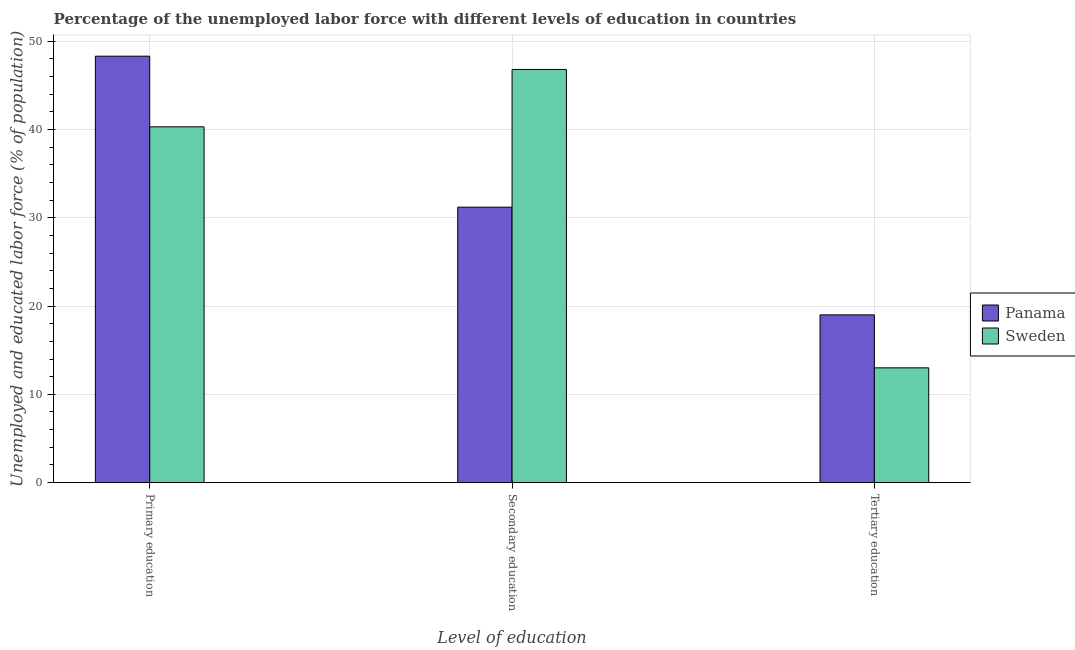How many different coloured bars are there?
Offer a terse response. 2. Are the number of bars per tick equal to the number of legend labels?
Your answer should be compact. Yes. What is the label of the 2nd group of bars from the left?
Provide a short and direct response. Secondary education. What is the percentage of labor force who received secondary education in Sweden?
Your response must be concise. 46.8. Across all countries, what is the maximum percentage of labor force who received secondary education?
Keep it short and to the point. 46.8. Across all countries, what is the minimum percentage of labor force who received primary education?
Give a very brief answer. 40.3. In which country was the percentage of labor force who received tertiary education maximum?
Provide a succinct answer. Panama. What is the total percentage of labor force who received primary education in the graph?
Provide a succinct answer. 88.6. What is the difference between the percentage of labor force who received secondary education in Sweden and that in Panama?
Your response must be concise. 15.6. What is the difference between the percentage of labor force who received primary education in Sweden and the percentage of labor force who received tertiary education in Panama?
Make the answer very short. 21.3. What is the difference between the percentage of labor force who received primary education and percentage of labor force who received tertiary education in Panama?
Keep it short and to the point. 29.3. What is the ratio of the percentage of labor force who received secondary education in Panama to that in Sweden?
Offer a very short reply. 0.67. What is the difference between the highest and the second highest percentage of labor force who received tertiary education?
Provide a short and direct response. 6. What is the difference between the highest and the lowest percentage of labor force who received tertiary education?
Your answer should be very brief. 6. Is the sum of the percentage of labor force who received secondary education in Panama and Sweden greater than the maximum percentage of labor force who received tertiary education across all countries?
Your answer should be compact. Yes. What does the 2nd bar from the right in Primary education represents?
Offer a very short reply. Panama. Is it the case that in every country, the sum of the percentage of labor force who received primary education and percentage of labor force who received secondary education is greater than the percentage of labor force who received tertiary education?
Ensure brevity in your answer.  Yes. Are all the bars in the graph horizontal?
Your answer should be compact. No. Are the values on the major ticks of Y-axis written in scientific E-notation?
Keep it short and to the point. No. Does the graph contain any zero values?
Ensure brevity in your answer.  No. Does the graph contain grids?
Offer a terse response. Yes. Where does the legend appear in the graph?
Provide a short and direct response. Center right. How many legend labels are there?
Keep it short and to the point. 2. How are the legend labels stacked?
Your response must be concise. Vertical. What is the title of the graph?
Make the answer very short. Percentage of the unemployed labor force with different levels of education in countries. Does "Sierra Leone" appear as one of the legend labels in the graph?
Your answer should be very brief. No. What is the label or title of the X-axis?
Your response must be concise. Level of education. What is the label or title of the Y-axis?
Provide a short and direct response. Unemployed and educated labor force (% of population). What is the Unemployed and educated labor force (% of population) in Panama in Primary education?
Your answer should be compact. 48.3. What is the Unemployed and educated labor force (% of population) in Sweden in Primary education?
Provide a succinct answer. 40.3. What is the Unemployed and educated labor force (% of population) of Panama in Secondary education?
Provide a short and direct response. 31.2. What is the Unemployed and educated labor force (% of population) in Sweden in Secondary education?
Your answer should be very brief. 46.8. Across all Level of education, what is the maximum Unemployed and educated labor force (% of population) in Panama?
Ensure brevity in your answer.  48.3. Across all Level of education, what is the maximum Unemployed and educated labor force (% of population) in Sweden?
Offer a terse response. 46.8. Across all Level of education, what is the minimum Unemployed and educated labor force (% of population) in Panama?
Keep it short and to the point. 19. Across all Level of education, what is the minimum Unemployed and educated labor force (% of population) in Sweden?
Offer a very short reply. 13. What is the total Unemployed and educated labor force (% of population) in Panama in the graph?
Make the answer very short. 98.5. What is the total Unemployed and educated labor force (% of population) in Sweden in the graph?
Give a very brief answer. 100.1. What is the difference between the Unemployed and educated labor force (% of population) in Panama in Primary education and that in Secondary education?
Your answer should be very brief. 17.1. What is the difference between the Unemployed and educated labor force (% of population) in Sweden in Primary education and that in Secondary education?
Keep it short and to the point. -6.5. What is the difference between the Unemployed and educated labor force (% of population) in Panama in Primary education and that in Tertiary education?
Offer a very short reply. 29.3. What is the difference between the Unemployed and educated labor force (% of population) of Sweden in Primary education and that in Tertiary education?
Provide a succinct answer. 27.3. What is the difference between the Unemployed and educated labor force (% of population) of Sweden in Secondary education and that in Tertiary education?
Your response must be concise. 33.8. What is the difference between the Unemployed and educated labor force (% of population) in Panama in Primary education and the Unemployed and educated labor force (% of population) in Sweden in Tertiary education?
Provide a short and direct response. 35.3. What is the average Unemployed and educated labor force (% of population) in Panama per Level of education?
Ensure brevity in your answer.  32.83. What is the average Unemployed and educated labor force (% of population) in Sweden per Level of education?
Give a very brief answer. 33.37. What is the difference between the Unemployed and educated labor force (% of population) of Panama and Unemployed and educated labor force (% of population) of Sweden in Primary education?
Offer a terse response. 8. What is the difference between the Unemployed and educated labor force (% of population) of Panama and Unemployed and educated labor force (% of population) of Sweden in Secondary education?
Keep it short and to the point. -15.6. What is the difference between the Unemployed and educated labor force (% of population) of Panama and Unemployed and educated labor force (% of population) of Sweden in Tertiary education?
Keep it short and to the point. 6. What is the ratio of the Unemployed and educated labor force (% of population) in Panama in Primary education to that in Secondary education?
Provide a succinct answer. 1.55. What is the ratio of the Unemployed and educated labor force (% of population) of Sweden in Primary education to that in Secondary education?
Offer a very short reply. 0.86. What is the ratio of the Unemployed and educated labor force (% of population) of Panama in Primary education to that in Tertiary education?
Provide a short and direct response. 2.54. What is the ratio of the Unemployed and educated labor force (% of population) in Panama in Secondary education to that in Tertiary education?
Keep it short and to the point. 1.64. What is the ratio of the Unemployed and educated labor force (% of population) of Sweden in Secondary education to that in Tertiary education?
Your answer should be compact. 3.6. What is the difference between the highest and the second highest Unemployed and educated labor force (% of population) in Panama?
Make the answer very short. 17.1. What is the difference between the highest and the second highest Unemployed and educated labor force (% of population) in Sweden?
Your answer should be compact. 6.5. What is the difference between the highest and the lowest Unemployed and educated labor force (% of population) in Panama?
Offer a terse response. 29.3. What is the difference between the highest and the lowest Unemployed and educated labor force (% of population) in Sweden?
Your answer should be compact. 33.8. 